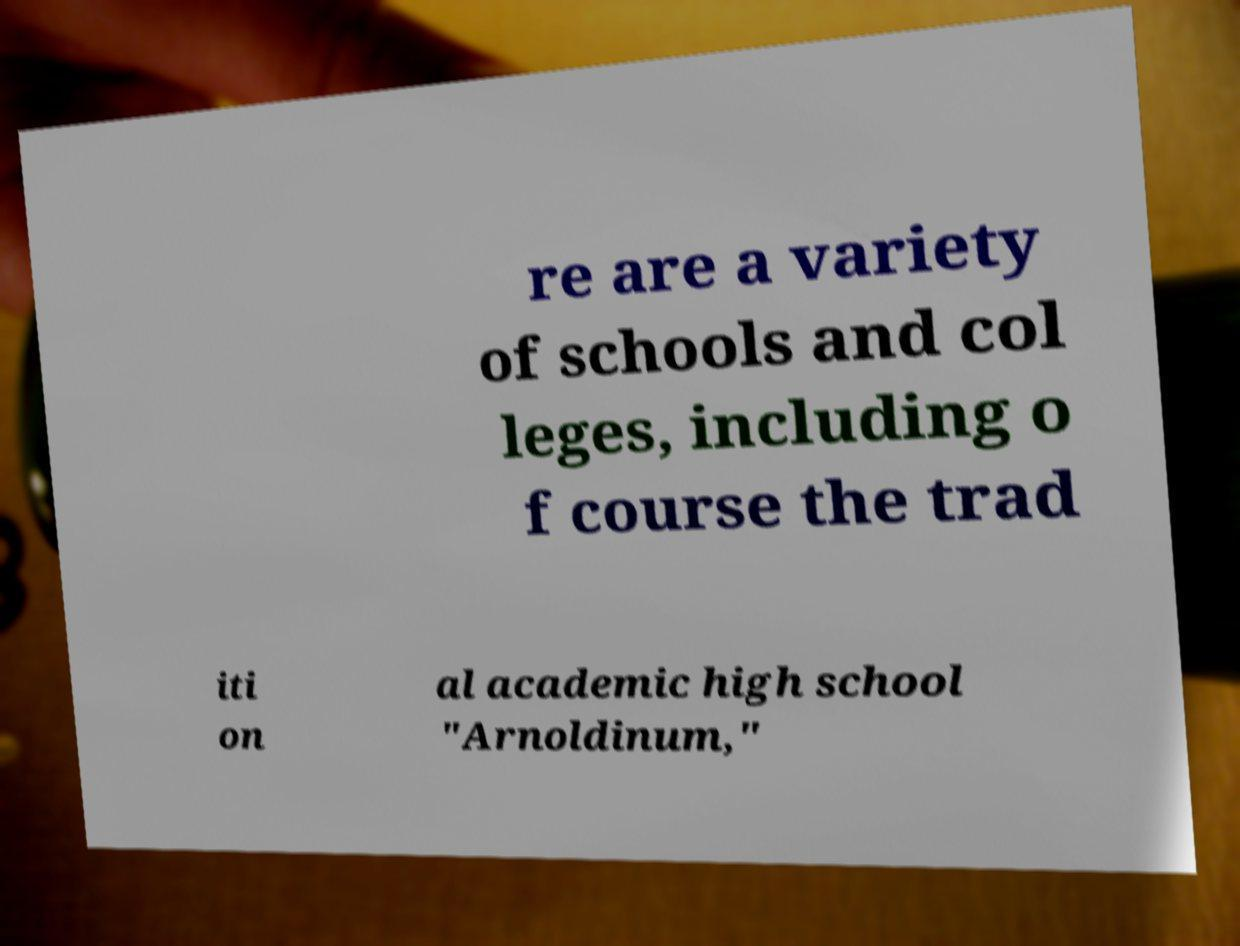What messages or text are displayed in this image? I need them in a readable, typed format. re are a variety of schools and col leges, including o f course the trad iti on al academic high school "Arnoldinum," 